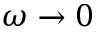<formula> <loc_0><loc_0><loc_500><loc_500>\omega \to 0</formula> 